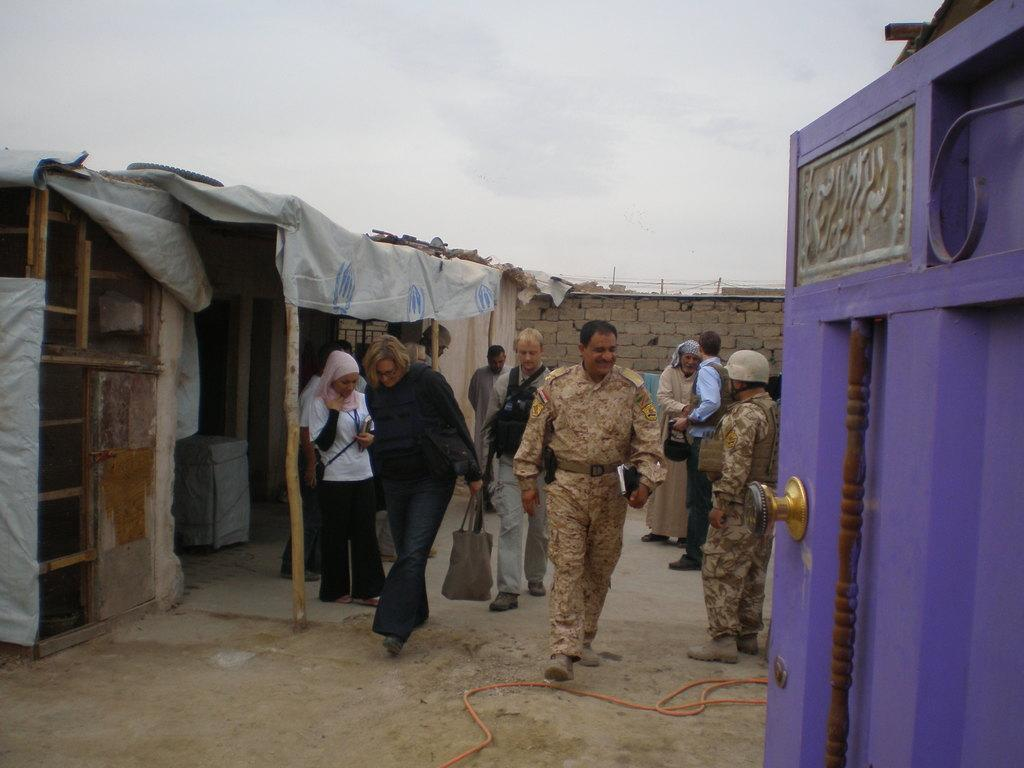What are the people in the image doing? The people in the image are walking. How can you describe the clothing of the people? The people are wearing different color dresses. What are some people carrying in the image? Some people are holding bags. What type of structures can be seen in the image? There are rooms visible in the image. What architectural features are present in the image? There are poles and a wall in the image. What color objects can be seen in the image? There are purple color objects in the image. What type of frogs can be seen hopping around in the image? There are no frogs present in the image; it features people walking and various structures. 